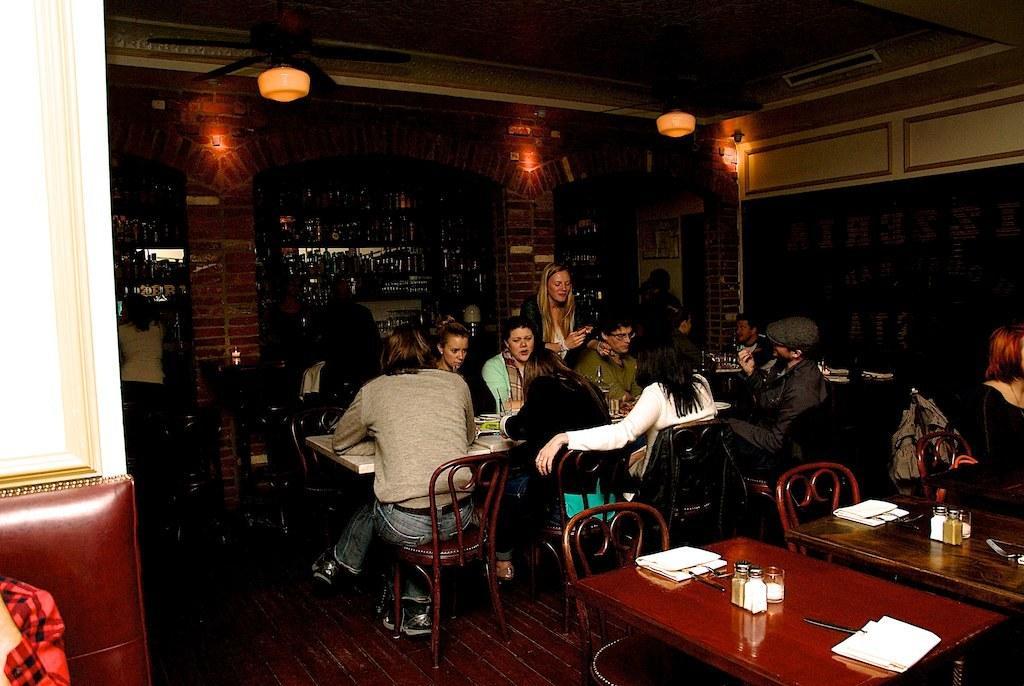Describe this image in one or two sentences. In this image i can see a group of people sitting on the chair. We have couple of tables with a few objects on it. Here we have a pillar of bricks and a glass of bottles. Here we have a lamp light and a wooden floor. 